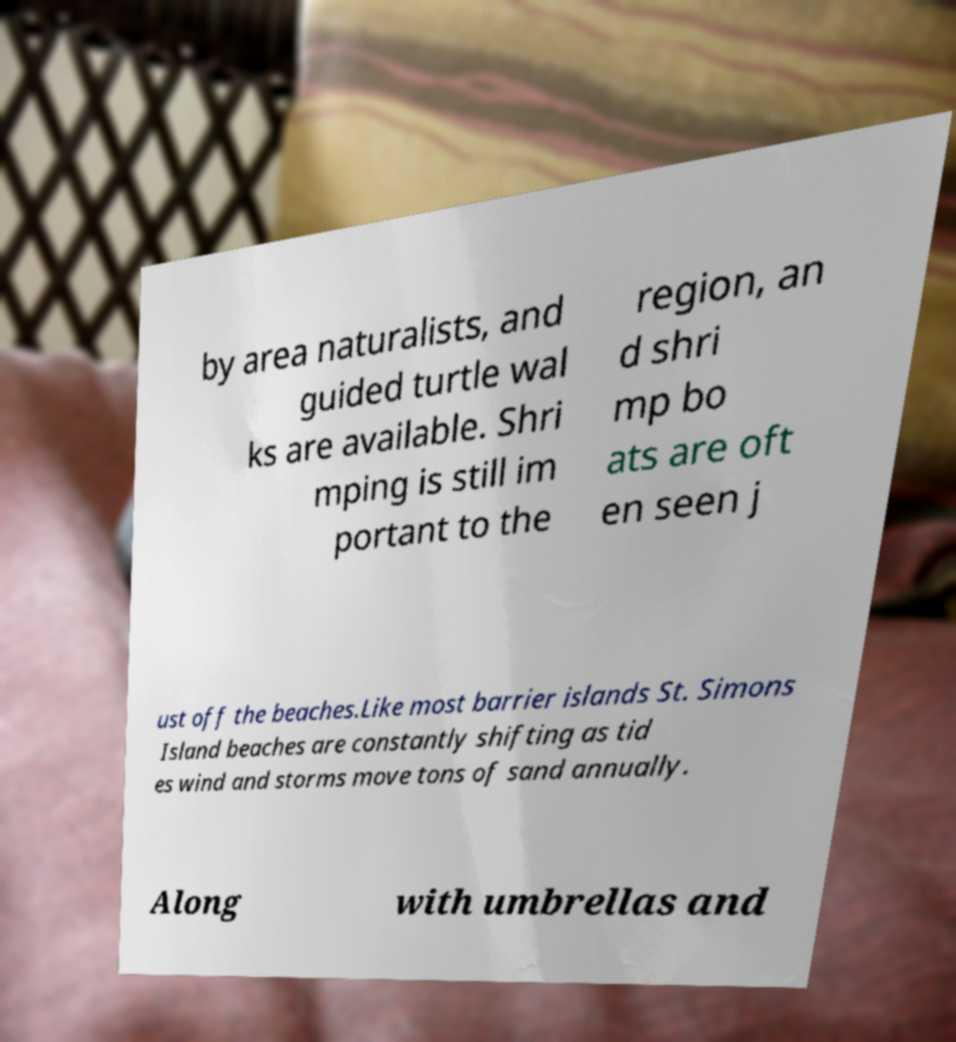Can you accurately transcribe the text from the provided image for me? by area naturalists, and guided turtle wal ks are available. Shri mping is still im portant to the region, an d shri mp bo ats are oft en seen j ust off the beaches.Like most barrier islands St. Simons Island beaches are constantly shifting as tid es wind and storms move tons of sand annually. Along with umbrellas and 